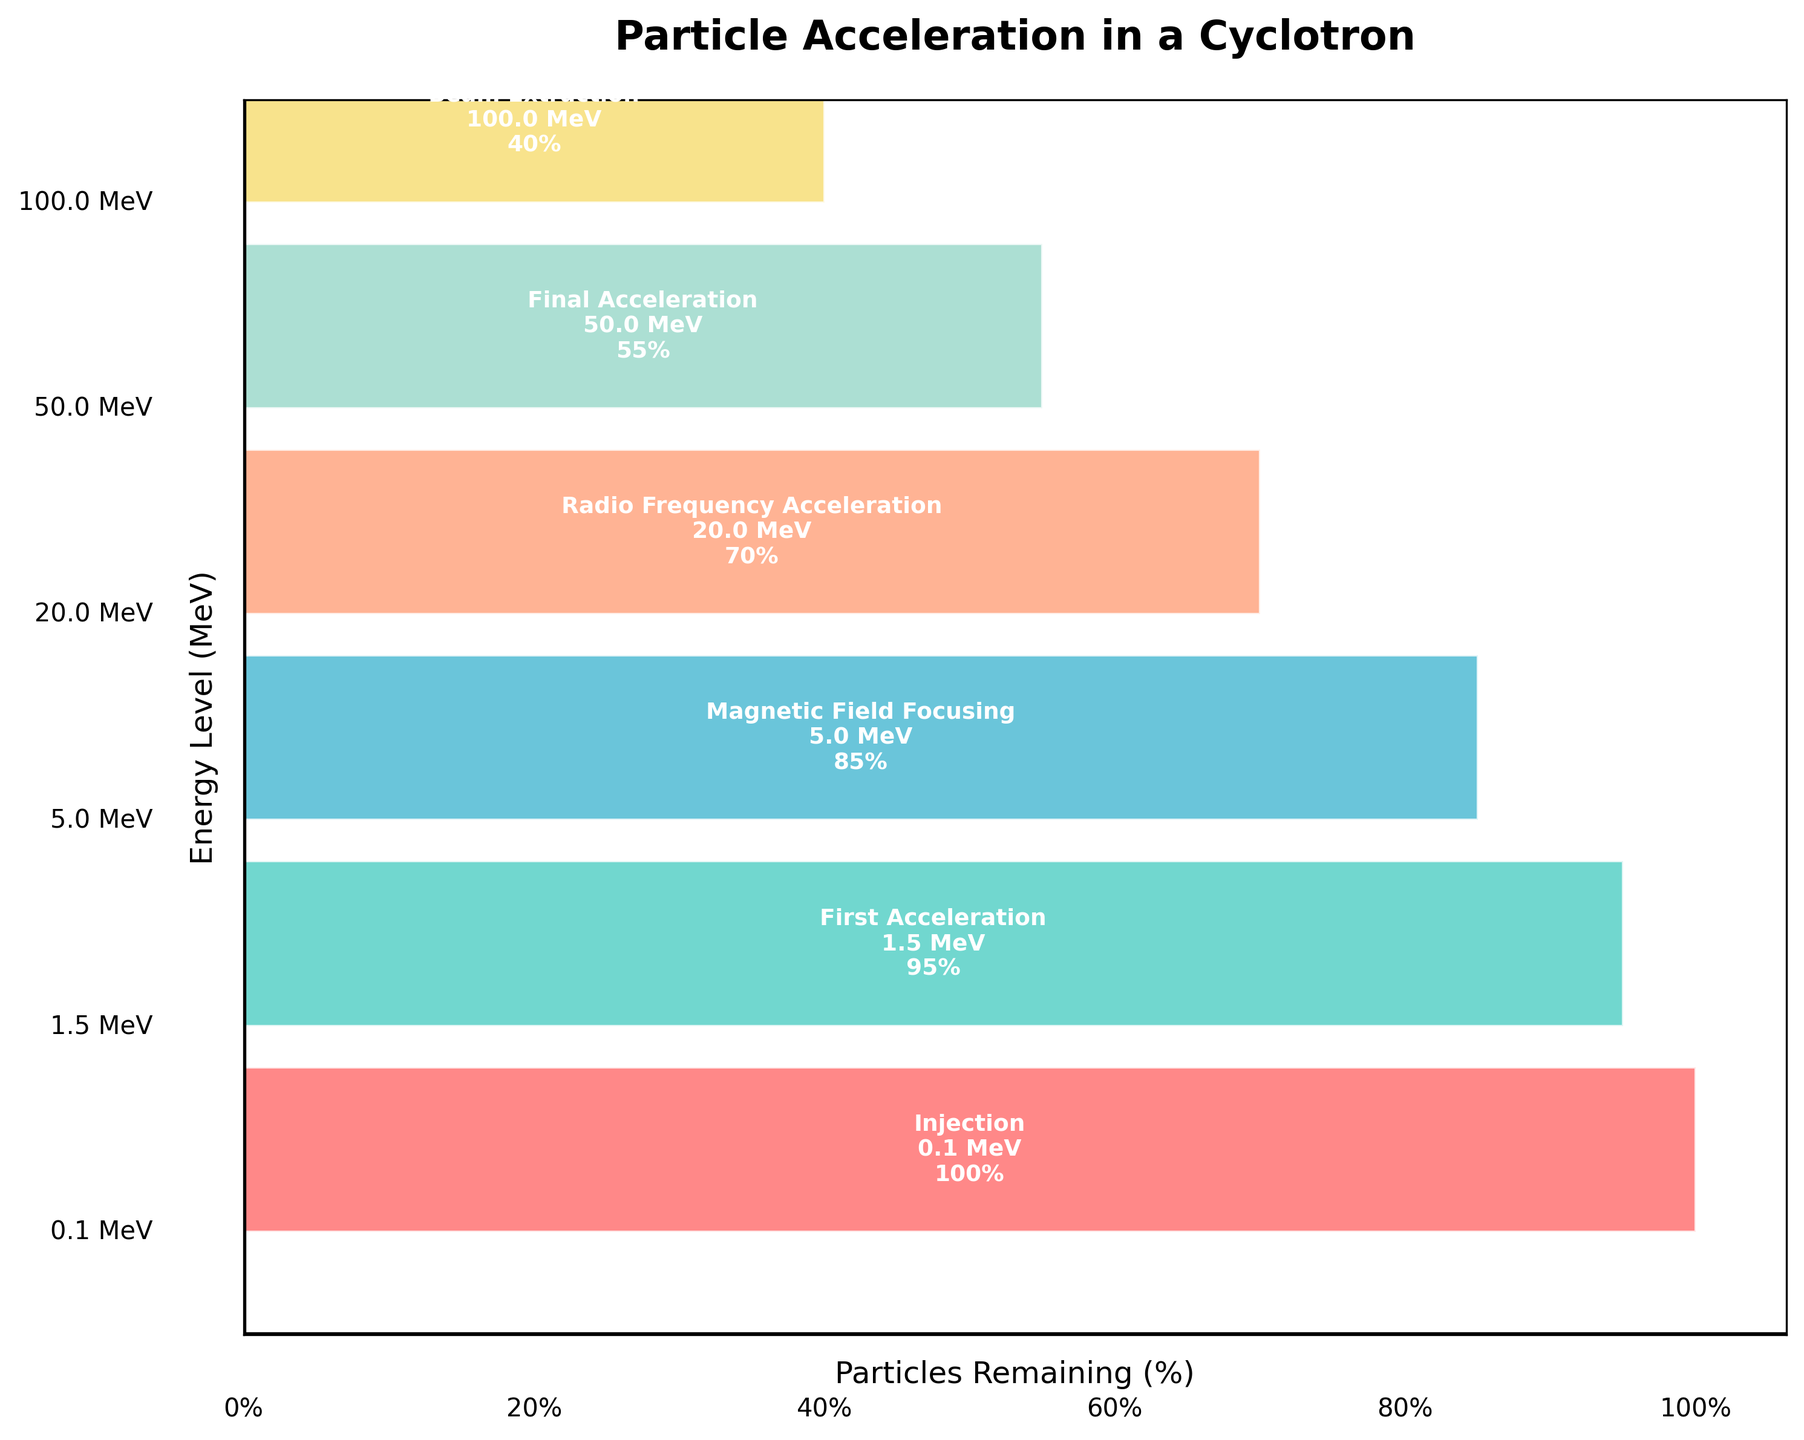What's the title of the figure? The title is displayed at the top of the figure.
Answer: "Particle Acceleration in a Cyclotron" What is the highest energy level shown in the figure? The energy levels are listed from the bottom to the top in the funnel stages. The highest energy level is at the top.
Answer: 100 MeV How many stages are there in the particle acceleration process as depicted in the figure? Count the distinct stages represented by different polygons in the funnel chart.
Answer: 6 Which stage has the highest percentage of particles remaining? Look for the stage with the widest polygon, as width represents the percentage of particles remaining.
Answer: Injection What percentage of particles remain after the Radio Frequency Acceleration stage? Locate the Radio Frequency Acceleration stage and read the corresponding percentage labeled inside the polygon.
Answer: 70% How much more energy is achieved in the Radio Frequency Acceleration stage compared to the First Acceleration stage? Subtract the energy level of the First Acceleration stage from that of the Radio Frequency Acceleration stage: 20 MeV - 1.5 MeV = 18.5 MeV.
Answer: 18.5 MeV Which stage has fewer particles remaining: Magnetic Field Focusing or Final Acceleration? Compare the percentages of particles remaining in the Magnetic Field Focusing (85%) and Final Acceleration (55%) stages.
Answer: Final Acceleration In which stage do particles achieve the energy level of 50 MeV? Locate the stage labeled with an energy level of 50 MeV inside its corresponding polygon.
Answer: Final Acceleration By how much does the particle percentage decrease from the Injection stage to the Beam Extraction stage? Subtract the percentage of particles remaining in the Beam Extraction stage from that in the Injection stage: 100% - 40% = 60%.
Answer: 60% What is the average energy level achieved across all stages? Add up all the energy levels and divide by the number of stages: (0.1 + 1.5 + 5 + 20 + 50 + 100) / 6 = 29.43 MeV.
Answer: 29.43 MeV 